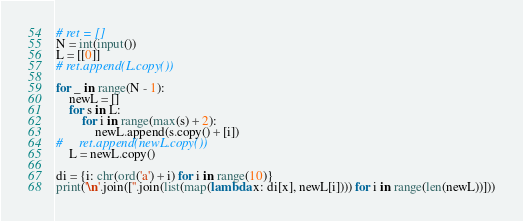Convert code to text. <code><loc_0><loc_0><loc_500><loc_500><_Python_># ret = []
N = int(input())
L = [[0]]
# ret.append(L.copy())

for _ in range(N - 1):
    newL = []
    for s in L:
        for i in range(max(s) + 2):
            newL.append(s.copy() + [i])
#     ret.append(newL.copy())
    L = newL.copy()
    
di = {i: chr(ord('a') + i) for i in range(10)}
print('\n'.join([''.join(list(map(lambda x: di[x], newL[i]))) for i in range(len(newL))]))</code> 